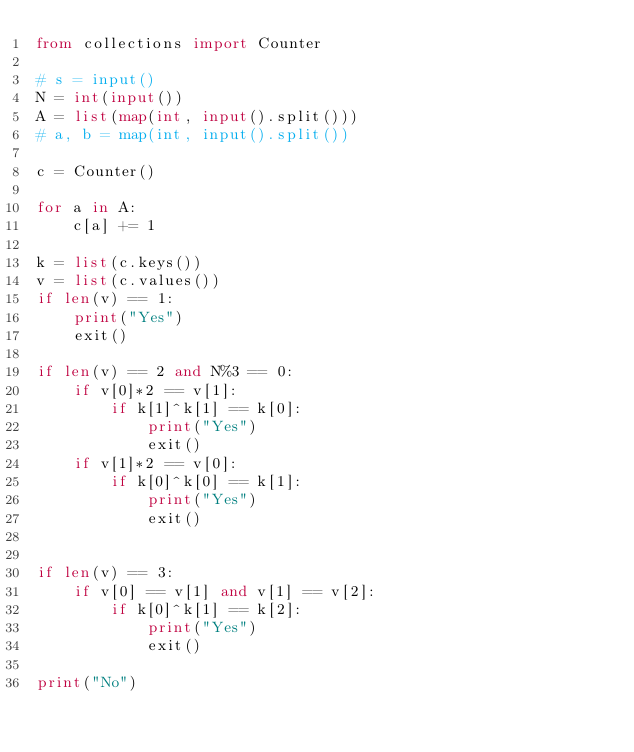Convert code to text. <code><loc_0><loc_0><loc_500><loc_500><_Python_>from collections import Counter

# s = input()
N = int(input())
A = list(map(int, input().split()))
# a, b = map(int, input().split())

c = Counter()

for a in A:
    c[a] += 1

k = list(c.keys())
v = list(c.values())
if len(v) == 1:
    print("Yes")
    exit()

if len(v) == 2 and N%3 == 0:
    if v[0]*2 == v[1]:
        if k[1]^k[1] == k[0]:
            print("Yes")
            exit()
    if v[1]*2 == v[0]:
        if k[0]^k[0] == k[1]:
            print("Yes")
            exit()


if len(v) == 3:
    if v[0] == v[1] and v[1] == v[2]:
        if k[0]^k[1] == k[2]:
            print("Yes")
            exit()

print("No")


</code> 